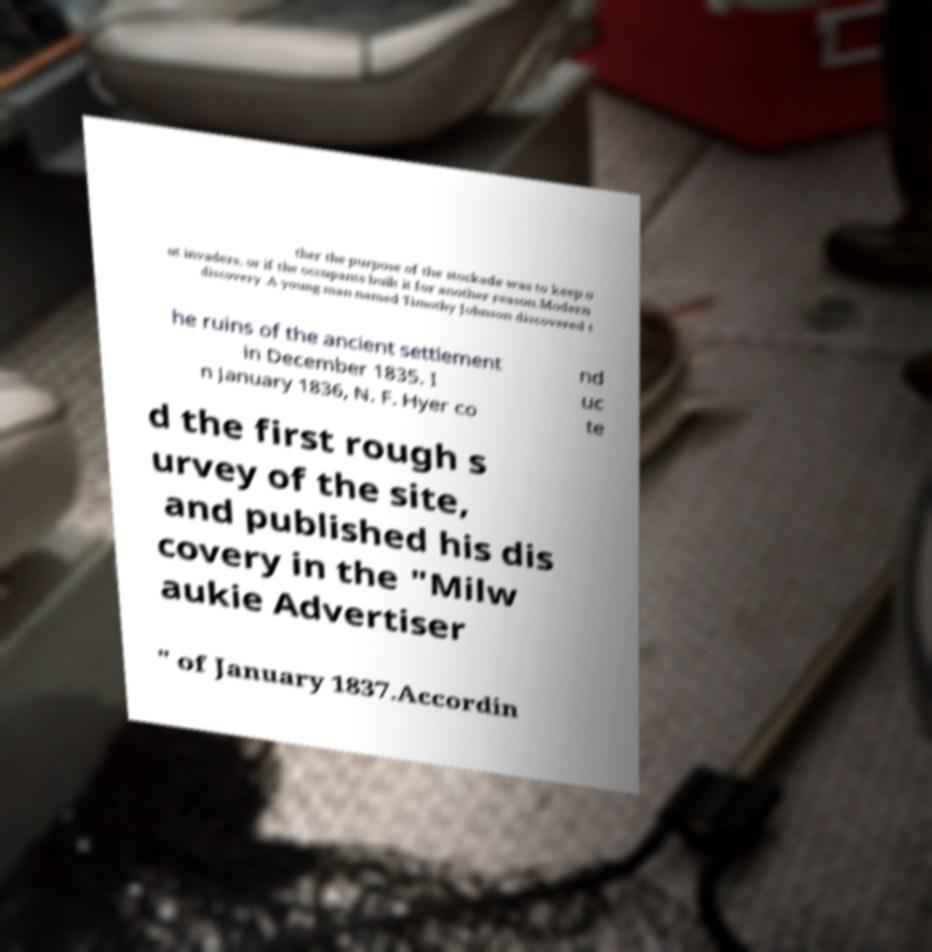Please read and relay the text visible in this image. What does it say? ther the purpose of the stockade was to keep o ut invaders, or if the occupants built it for another reason.Modern discovery .A young man named Timothy Johnson discovered t he ruins of the ancient settlement in December 1835. I n January 1836, N. F. Hyer co nd uc te d the first rough s urvey of the site, and published his dis covery in the "Milw aukie Advertiser " of January 1837.Accordin 